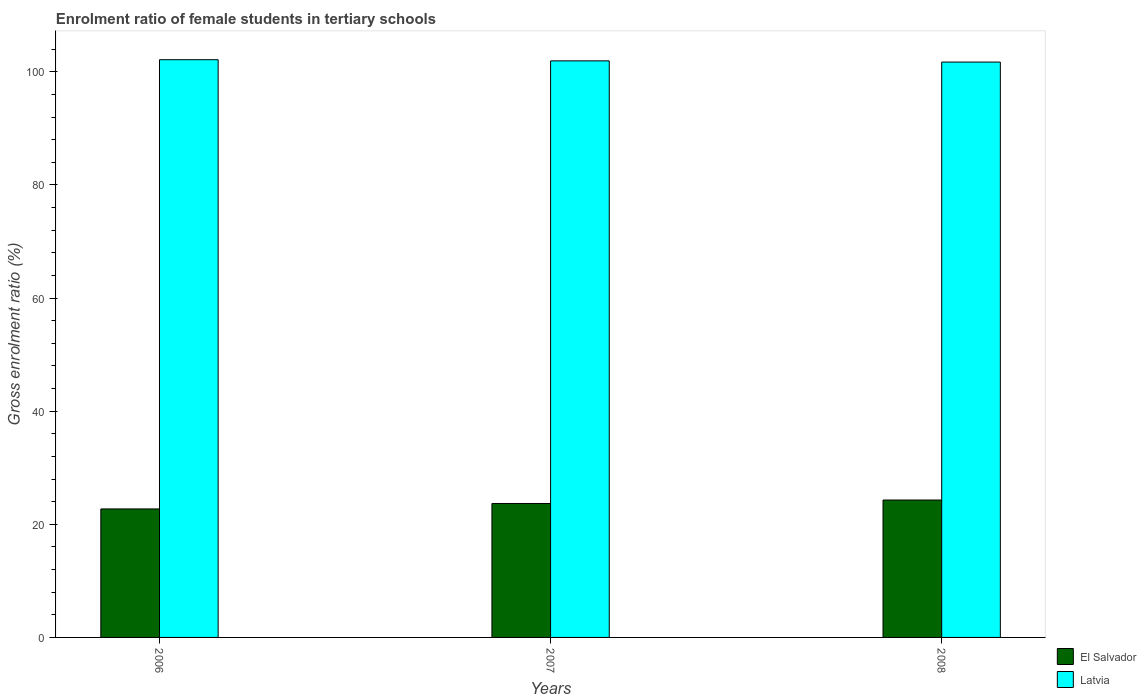How many different coloured bars are there?
Offer a very short reply. 2. How many groups of bars are there?
Ensure brevity in your answer.  3. Are the number of bars per tick equal to the number of legend labels?
Provide a succinct answer. Yes. How many bars are there on the 2nd tick from the left?
Give a very brief answer. 2. What is the label of the 3rd group of bars from the left?
Your answer should be very brief. 2008. In how many cases, is the number of bars for a given year not equal to the number of legend labels?
Your answer should be compact. 0. What is the enrolment ratio of female students in tertiary schools in El Salvador in 2007?
Provide a succinct answer. 23.68. Across all years, what is the maximum enrolment ratio of female students in tertiary schools in El Salvador?
Provide a short and direct response. 24.29. Across all years, what is the minimum enrolment ratio of female students in tertiary schools in Latvia?
Offer a terse response. 101.72. In which year was the enrolment ratio of female students in tertiary schools in El Salvador minimum?
Your response must be concise. 2006. What is the total enrolment ratio of female students in tertiary schools in El Salvador in the graph?
Provide a succinct answer. 70.69. What is the difference between the enrolment ratio of female students in tertiary schools in El Salvador in 2006 and that in 2007?
Your answer should be very brief. -0.96. What is the difference between the enrolment ratio of female students in tertiary schools in Latvia in 2007 and the enrolment ratio of female students in tertiary schools in El Salvador in 2008?
Provide a succinct answer. 77.64. What is the average enrolment ratio of female students in tertiary schools in El Salvador per year?
Your answer should be very brief. 23.56. In the year 2008, what is the difference between the enrolment ratio of female students in tertiary schools in Latvia and enrolment ratio of female students in tertiary schools in El Salvador?
Your response must be concise. 77.43. In how many years, is the enrolment ratio of female students in tertiary schools in Latvia greater than 32 %?
Offer a terse response. 3. What is the ratio of the enrolment ratio of female students in tertiary schools in El Salvador in 2006 to that in 2008?
Provide a succinct answer. 0.94. Is the enrolment ratio of female students in tertiary schools in El Salvador in 2006 less than that in 2008?
Your response must be concise. Yes. Is the difference between the enrolment ratio of female students in tertiary schools in Latvia in 2006 and 2008 greater than the difference between the enrolment ratio of female students in tertiary schools in El Salvador in 2006 and 2008?
Your response must be concise. Yes. What is the difference between the highest and the second highest enrolment ratio of female students in tertiary schools in El Salvador?
Your answer should be compact. 0.61. What is the difference between the highest and the lowest enrolment ratio of female students in tertiary schools in El Salvador?
Keep it short and to the point. 1.57. What does the 1st bar from the left in 2007 represents?
Your answer should be very brief. El Salvador. What does the 2nd bar from the right in 2006 represents?
Make the answer very short. El Salvador. How many years are there in the graph?
Offer a terse response. 3. Are the values on the major ticks of Y-axis written in scientific E-notation?
Your answer should be compact. No. Does the graph contain grids?
Offer a terse response. No. What is the title of the graph?
Give a very brief answer. Enrolment ratio of female students in tertiary schools. What is the Gross enrolment ratio (%) of El Salvador in 2006?
Keep it short and to the point. 22.72. What is the Gross enrolment ratio (%) in Latvia in 2006?
Offer a very short reply. 102.13. What is the Gross enrolment ratio (%) in El Salvador in 2007?
Ensure brevity in your answer.  23.68. What is the Gross enrolment ratio (%) of Latvia in 2007?
Your answer should be very brief. 101.93. What is the Gross enrolment ratio (%) of El Salvador in 2008?
Provide a succinct answer. 24.29. What is the Gross enrolment ratio (%) of Latvia in 2008?
Ensure brevity in your answer.  101.72. Across all years, what is the maximum Gross enrolment ratio (%) in El Salvador?
Your answer should be very brief. 24.29. Across all years, what is the maximum Gross enrolment ratio (%) of Latvia?
Your answer should be very brief. 102.13. Across all years, what is the minimum Gross enrolment ratio (%) in El Salvador?
Give a very brief answer. 22.72. Across all years, what is the minimum Gross enrolment ratio (%) in Latvia?
Keep it short and to the point. 101.72. What is the total Gross enrolment ratio (%) in El Salvador in the graph?
Offer a terse response. 70.69. What is the total Gross enrolment ratio (%) of Latvia in the graph?
Your answer should be very brief. 305.78. What is the difference between the Gross enrolment ratio (%) in El Salvador in 2006 and that in 2007?
Offer a terse response. -0.96. What is the difference between the Gross enrolment ratio (%) in Latvia in 2006 and that in 2007?
Offer a terse response. 0.2. What is the difference between the Gross enrolment ratio (%) of El Salvador in 2006 and that in 2008?
Your answer should be compact. -1.57. What is the difference between the Gross enrolment ratio (%) of Latvia in 2006 and that in 2008?
Provide a short and direct response. 0.42. What is the difference between the Gross enrolment ratio (%) in El Salvador in 2007 and that in 2008?
Your answer should be compact. -0.61. What is the difference between the Gross enrolment ratio (%) in Latvia in 2007 and that in 2008?
Your response must be concise. 0.21. What is the difference between the Gross enrolment ratio (%) of El Salvador in 2006 and the Gross enrolment ratio (%) of Latvia in 2007?
Ensure brevity in your answer.  -79.21. What is the difference between the Gross enrolment ratio (%) in El Salvador in 2006 and the Gross enrolment ratio (%) in Latvia in 2008?
Provide a short and direct response. -79. What is the difference between the Gross enrolment ratio (%) in El Salvador in 2007 and the Gross enrolment ratio (%) in Latvia in 2008?
Your answer should be very brief. -78.04. What is the average Gross enrolment ratio (%) of El Salvador per year?
Give a very brief answer. 23.56. What is the average Gross enrolment ratio (%) of Latvia per year?
Your answer should be compact. 101.93. In the year 2006, what is the difference between the Gross enrolment ratio (%) in El Salvador and Gross enrolment ratio (%) in Latvia?
Provide a short and direct response. -79.42. In the year 2007, what is the difference between the Gross enrolment ratio (%) of El Salvador and Gross enrolment ratio (%) of Latvia?
Provide a short and direct response. -78.25. In the year 2008, what is the difference between the Gross enrolment ratio (%) in El Salvador and Gross enrolment ratio (%) in Latvia?
Make the answer very short. -77.43. What is the ratio of the Gross enrolment ratio (%) of El Salvador in 2006 to that in 2007?
Provide a succinct answer. 0.96. What is the ratio of the Gross enrolment ratio (%) in Latvia in 2006 to that in 2007?
Your answer should be compact. 1. What is the ratio of the Gross enrolment ratio (%) in El Salvador in 2006 to that in 2008?
Offer a very short reply. 0.94. What is the ratio of the Gross enrolment ratio (%) of El Salvador in 2007 to that in 2008?
Give a very brief answer. 0.97. What is the difference between the highest and the second highest Gross enrolment ratio (%) in El Salvador?
Your response must be concise. 0.61. What is the difference between the highest and the second highest Gross enrolment ratio (%) in Latvia?
Offer a very short reply. 0.2. What is the difference between the highest and the lowest Gross enrolment ratio (%) of El Salvador?
Keep it short and to the point. 1.57. What is the difference between the highest and the lowest Gross enrolment ratio (%) of Latvia?
Ensure brevity in your answer.  0.42. 